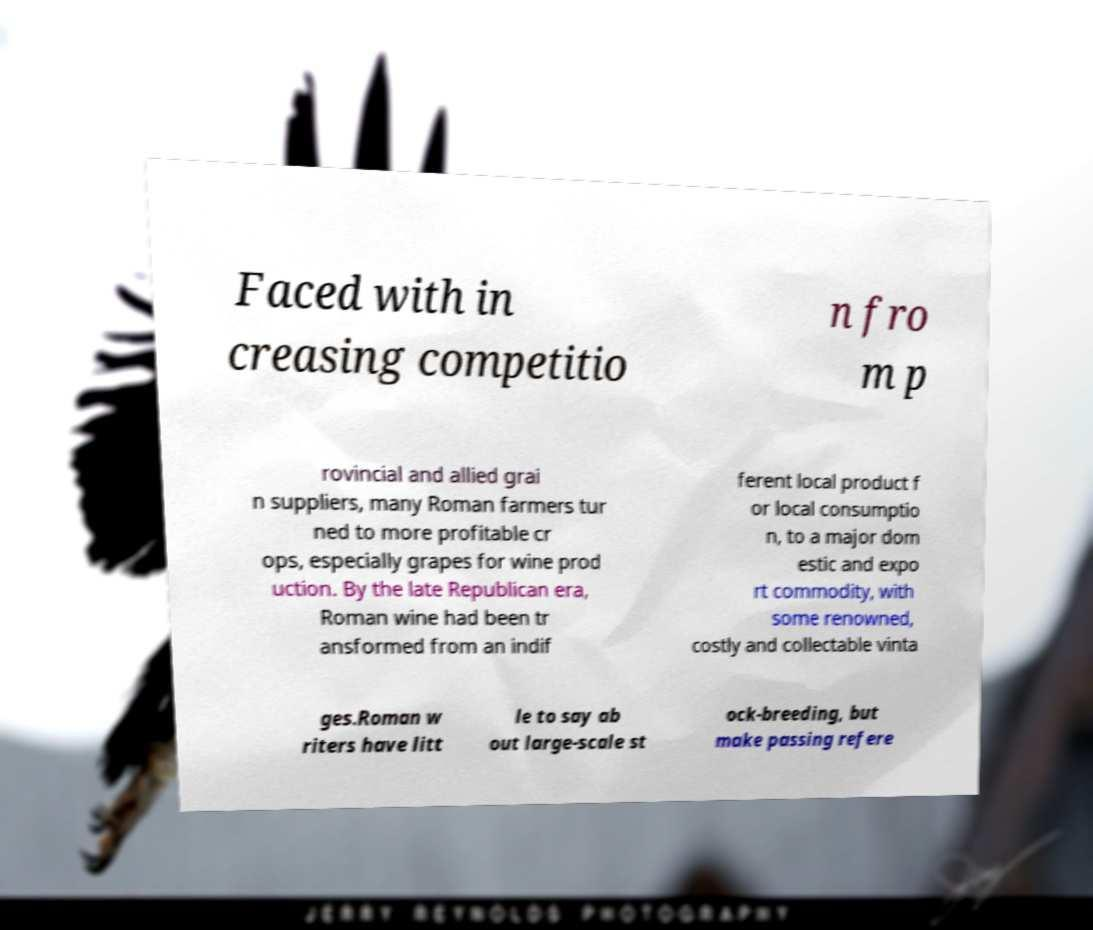I need the written content from this picture converted into text. Can you do that? Faced with in creasing competitio n fro m p rovincial and allied grai n suppliers, many Roman farmers tur ned to more profitable cr ops, especially grapes for wine prod uction. By the late Republican era, Roman wine had been tr ansformed from an indif ferent local product f or local consumptio n, to a major dom estic and expo rt commodity, with some renowned, costly and collectable vinta ges.Roman w riters have litt le to say ab out large-scale st ock-breeding, but make passing refere 